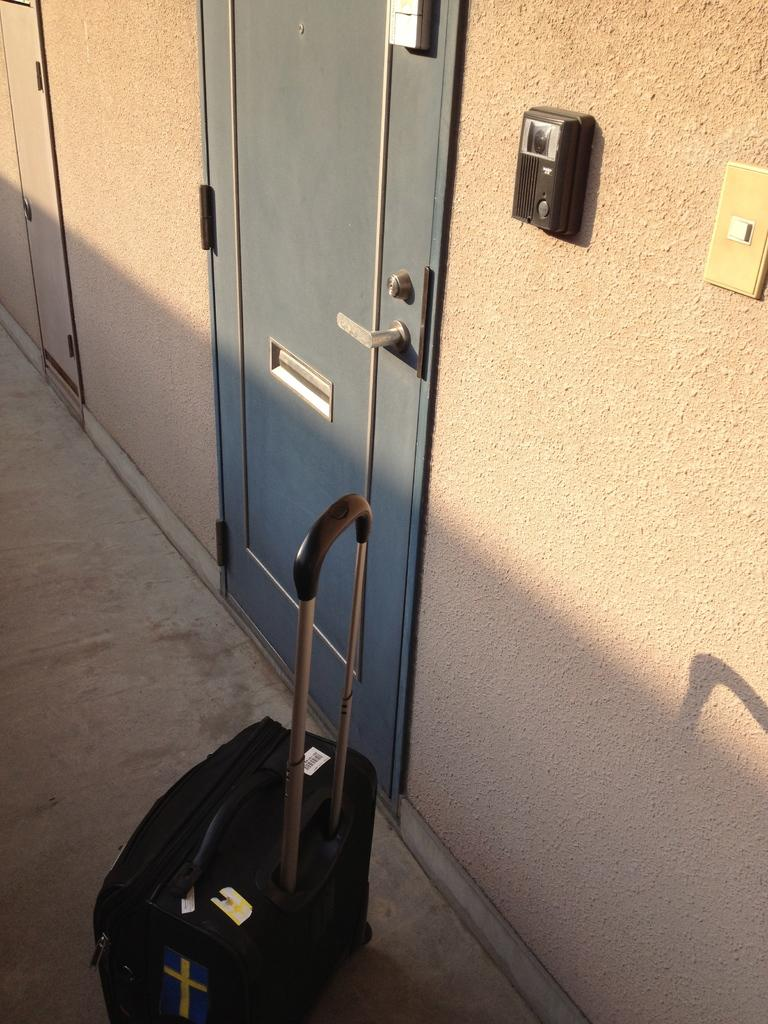What is the main object in the image? There is a door with a handle in the image. Can you describe the door in more detail? The door has a handle, which suggests it can be opened and closed. What else can be seen in the image? There is a luggage in black color in the image. Can you describe the luggage? The luggage is black, which indicates its color, but we cannot determine its size, shape, or other features from the provided facts. How does the porter help the traveler in the image? There is no porter present in the image, so we cannot determine how a porter might help a traveler in this context. 